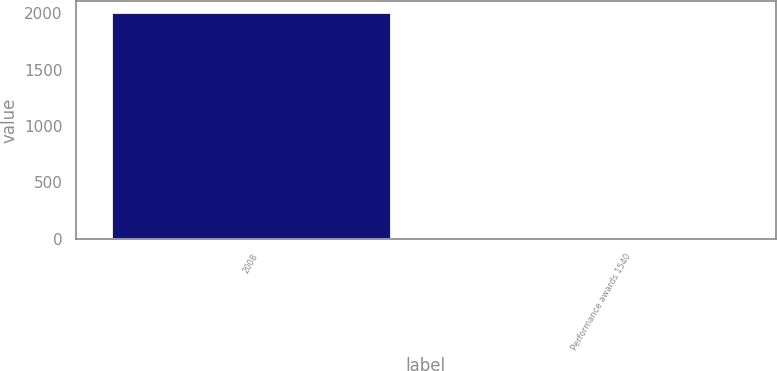<chart> <loc_0><loc_0><loc_500><loc_500><bar_chart><fcel>2008<fcel>Performance awards 1540<nl><fcel>2010<fcel>14.21<nl></chart> 